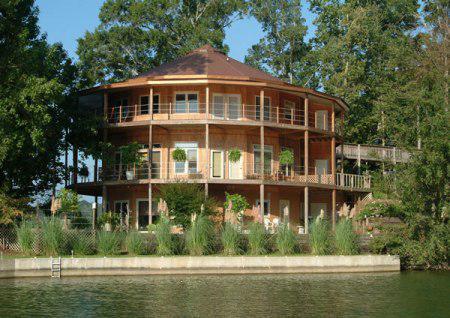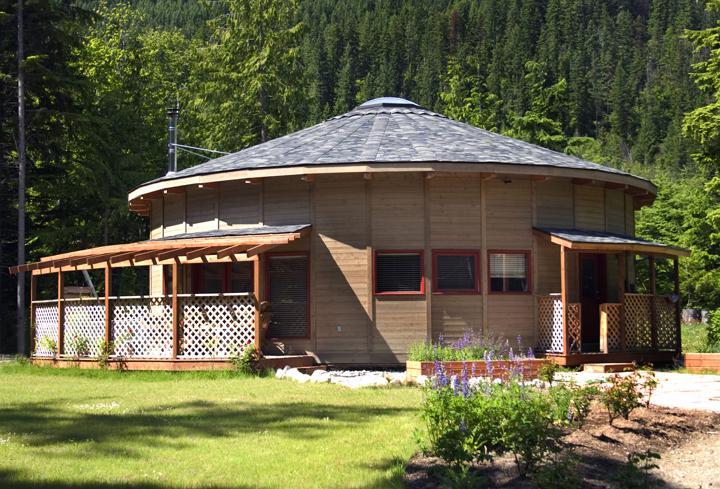The first image is the image on the left, the second image is the image on the right. Examine the images to the left and right. Is the description "A yurt in one image features a white door with nine-pane window and a wooden walkway, but has no visible windows." accurate? Answer yes or no. No. The first image is the image on the left, the second image is the image on the right. Analyze the images presented: Is the assertion "One image shows a yurt standing on a fresh-water shore, and the other image shows a yurt with decks extending from it and evergreens behind it." valid? Answer yes or no. Yes. 